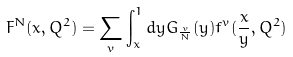Convert formula to latex. <formula><loc_0><loc_0><loc_500><loc_500>F ^ { N } ( x , Q ^ { 2 } ) = \sum _ { v } \int _ { x } ^ { 1 } d y G _ { \frac { v } { N } } ( y ) f ^ { v } ( \frac { x } { y } , Q ^ { 2 } )</formula> 